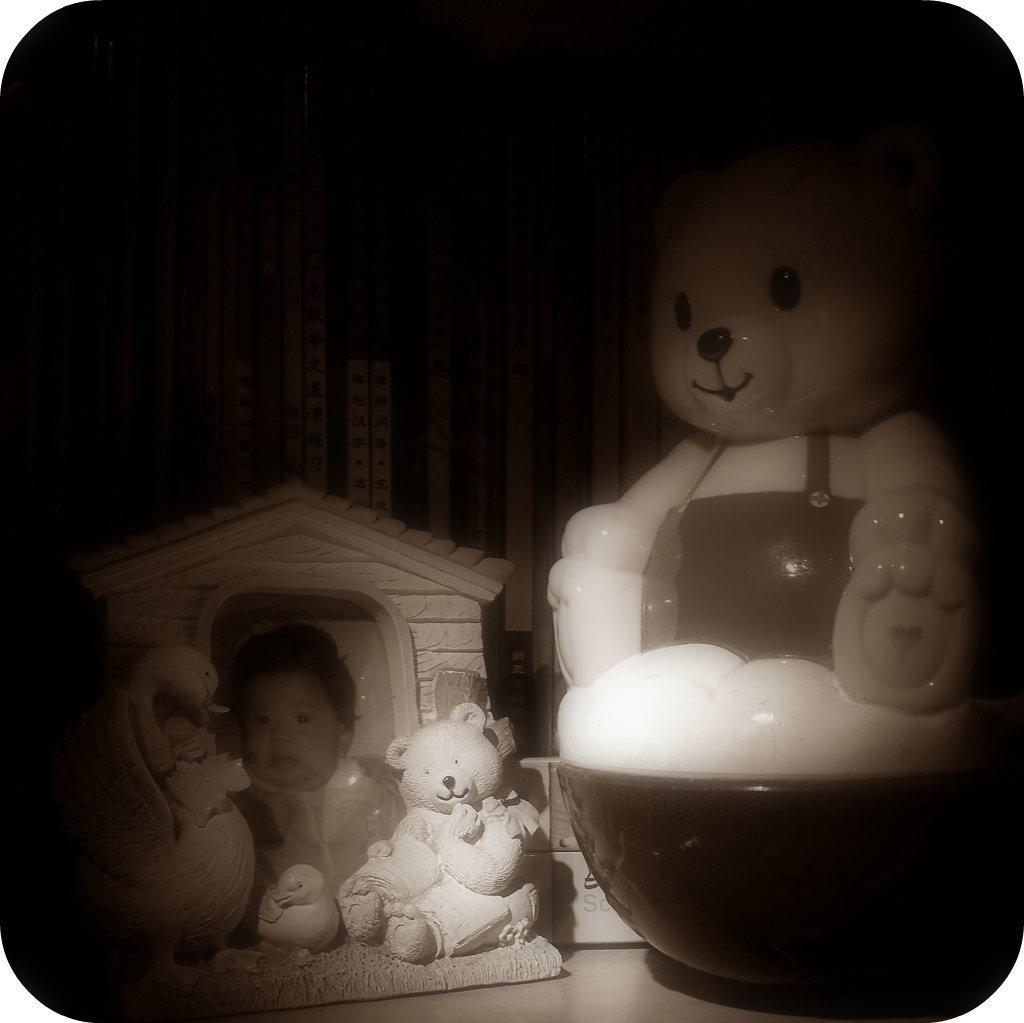What object in the image is typically used for displaying photos? There is a photo frame in the image. What type of items can be seen in the image that are often associated with children? There are toys present in the image. How many eyes can be seen on the rail in the image? There is no rail present in the image, and therefore no eyes can be seen on it. 